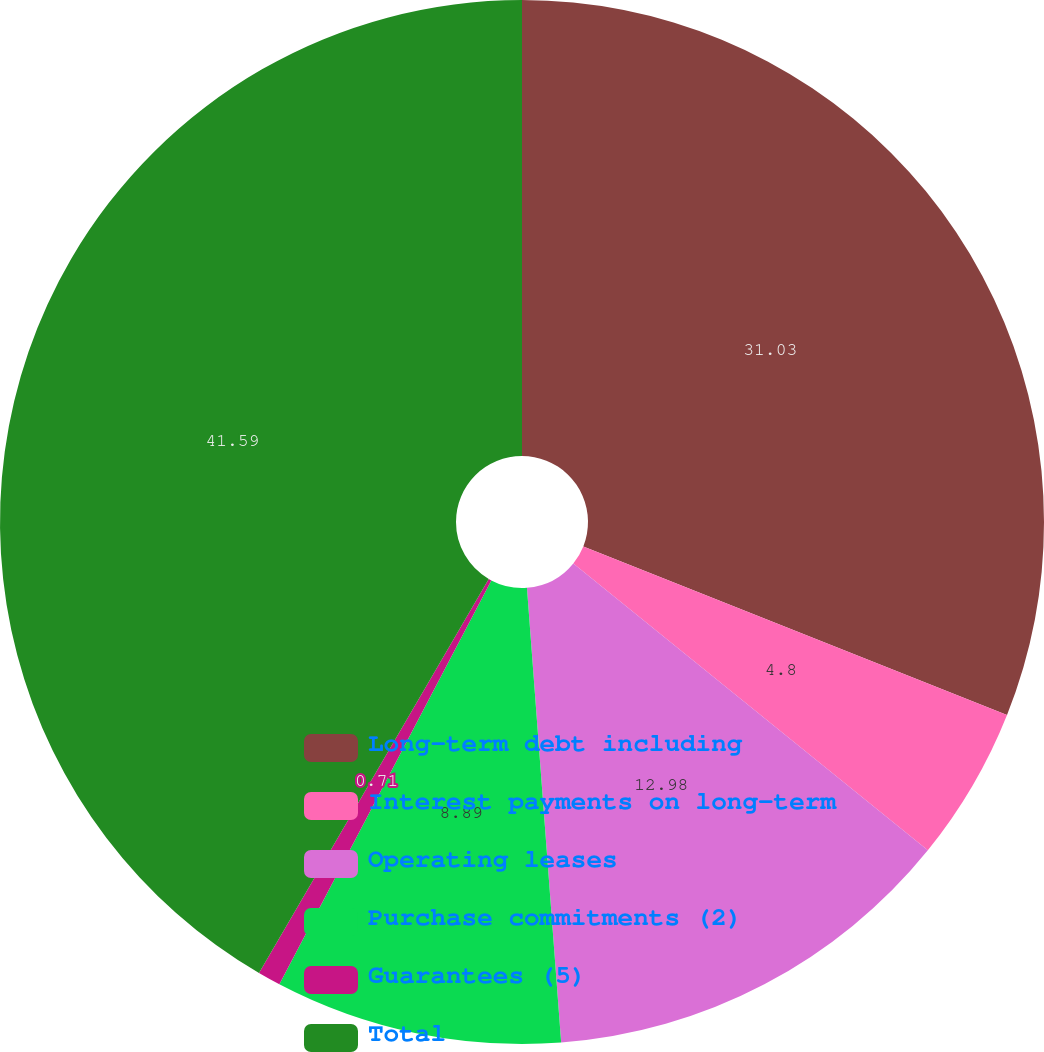Convert chart. <chart><loc_0><loc_0><loc_500><loc_500><pie_chart><fcel>Long-term debt including<fcel>Interest payments on long-term<fcel>Operating leases<fcel>Purchase commitments (2)<fcel>Guarantees (5)<fcel>Total<nl><fcel>31.03%<fcel>4.8%<fcel>12.98%<fcel>8.89%<fcel>0.71%<fcel>41.6%<nl></chart> 